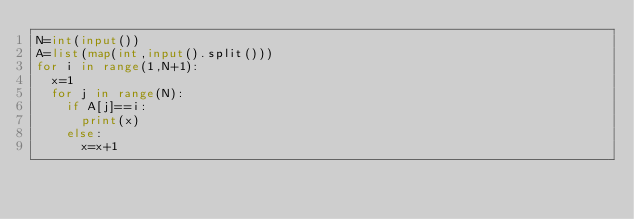<code> <loc_0><loc_0><loc_500><loc_500><_Python_>N=int(input())
A=list(map(int,input().split()))
for i in range(1,N+1):
  x=1
  for j in range(N):
    if A[j]==i:
      print(x)
    else:
      x=x+1</code> 